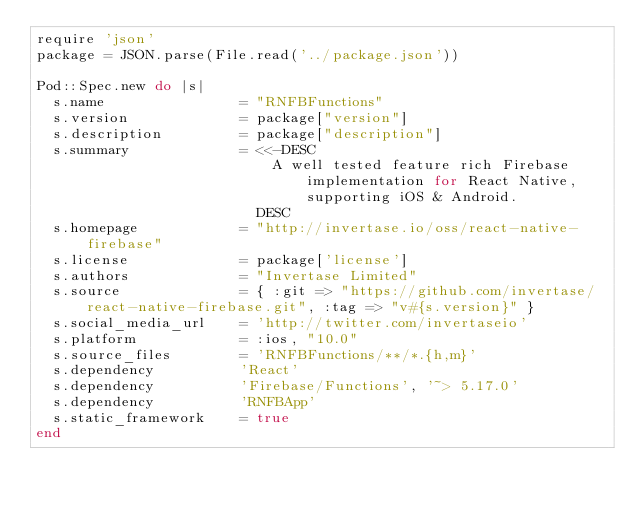<code> <loc_0><loc_0><loc_500><loc_500><_Ruby_>require 'json'
package = JSON.parse(File.read('../package.json'))

Pod::Spec.new do |s|
  s.name                = "RNFBFunctions"
  s.version             = package["version"]
  s.description         = package["description"]
  s.summary             = <<-DESC
                            A well tested feature rich Firebase implementation for React Native, supporting iOS & Android.
                          DESC
  s.homepage            = "http://invertase.io/oss/react-native-firebase"
  s.license             = package['license']
  s.authors             = "Invertase Limited"
  s.source              = { :git => "https://github.com/invertase/react-native-firebase.git", :tag => "v#{s.version}" }
  s.social_media_url    = 'http://twitter.com/invertaseio'
  s.platform            = :ios, "10.0"
  s.source_files        = 'RNFBFunctions/**/*.{h,m}'
  s.dependency          'React'
  s.dependency          'Firebase/Functions', '~> 5.17.0'
  s.dependency          'RNFBApp'
  s.static_framework    = true
end
</code> 